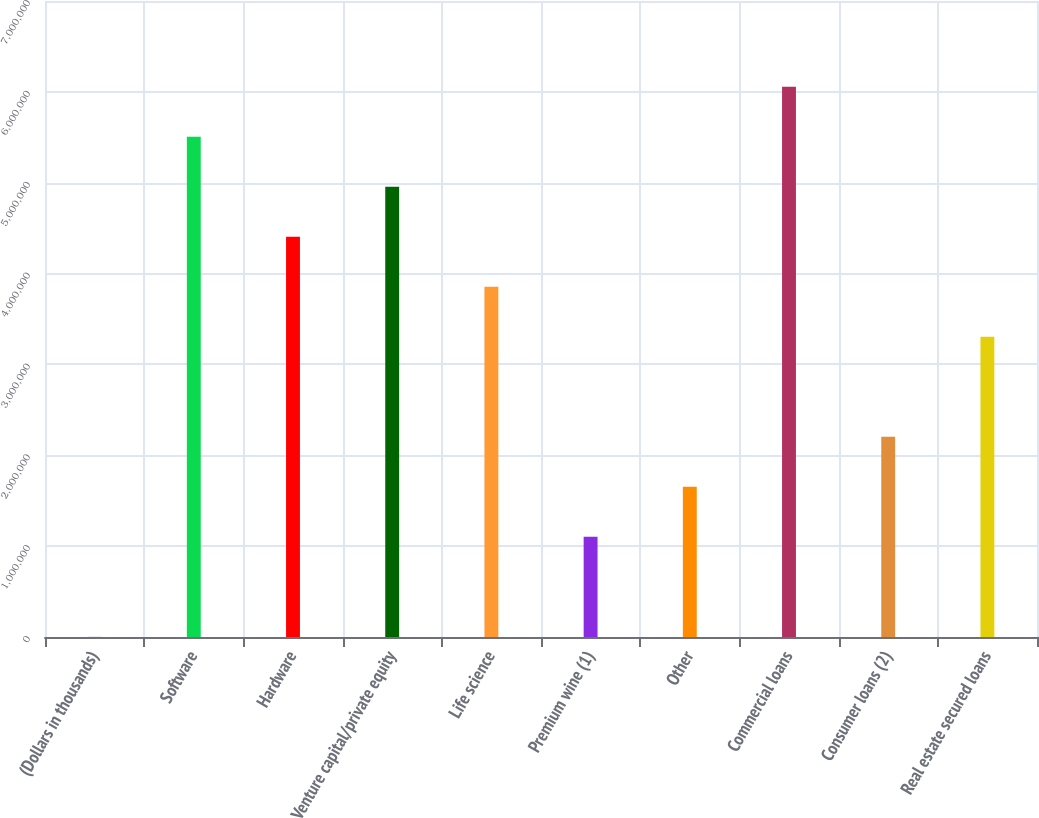<chart> <loc_0><loc_0><loc_500><loc_500><bar_chart><fcel>(Dollars in thousands)<fcel>Software<fcel>Hardware<fcel>Venture capital/private equity<fcel>Life science<fcel>Premium wine (1)<fcel>Other<fcel>Commercial loans<fcel>Consumer loans (2)<fcel>Real estate secured loans<nl><fcel>2008<fcel>5.50625e+06<fcel>4.4054e+06<fcel>4.95583e+06<fcel>3.85498e+06<fcel>1.10286e+06<fcel>1.65328e+06<fcel>6.05668e+06<fcel>2.20371e+06<fcel>3.30456e+06<nl></chart> 